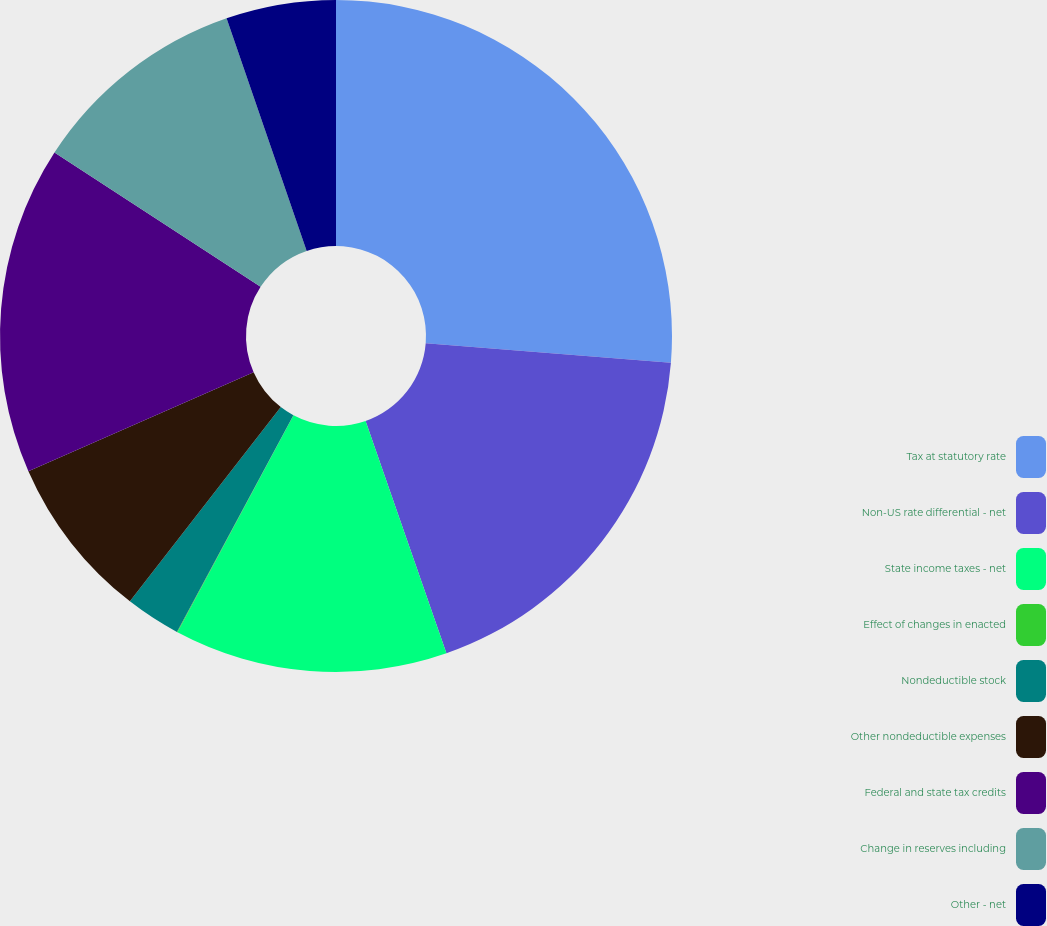Convert chart to OTSL. <chart><loc_0><loc_0><loc_500><loc_500><pie_chart><fcel>Tax at statutory rate<fcel>Non-US rate differential - net<fcel>State income taxes - net<fcel>Effect of changes in enacted<fcel>Nondeductible stock<fcel>Other nondeductible expenses<fcel>Federal and state tax credits<fcel>Change in reserves including<fcel>Other - net<nl><fcel>26.27%<fcel>18.4%<fcel>13.15%<fcel>0.03%<fcel>2.66%<fcel>7.9%<fcel>15.78%<fcel>10.53%<fcel>5.28%<nl></chart> 